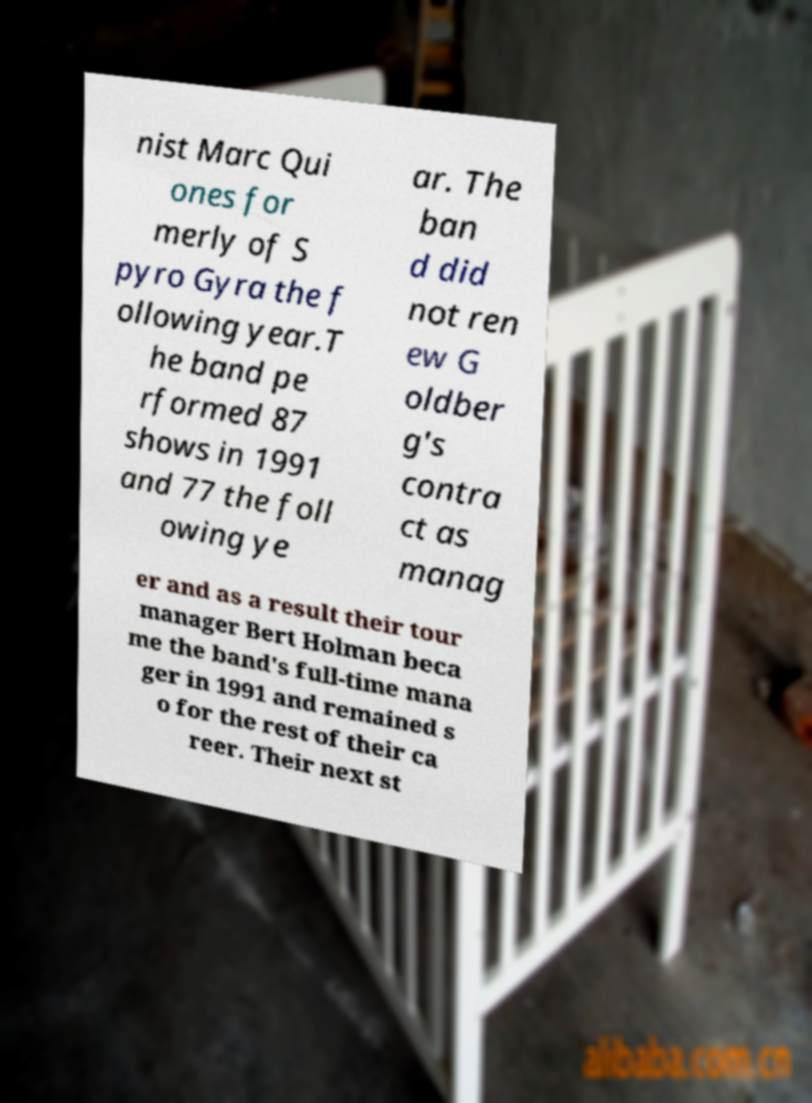There's text embedded in this image that I need extracted. Can you transcribe it verbatim? nist Marc Qui ones for merly of S pyro Gyra the f ollowing year.T he band pe rformed 87 shows in 1991 and 77 the foll owing ye ar. The ban d did not ren ew G oldber g's contra ct as manag er and as a result their tour manager Bert Holman beca me the band's full-time mana ger in 1991 and remained s o for the rest of their ca reer. Their next st 